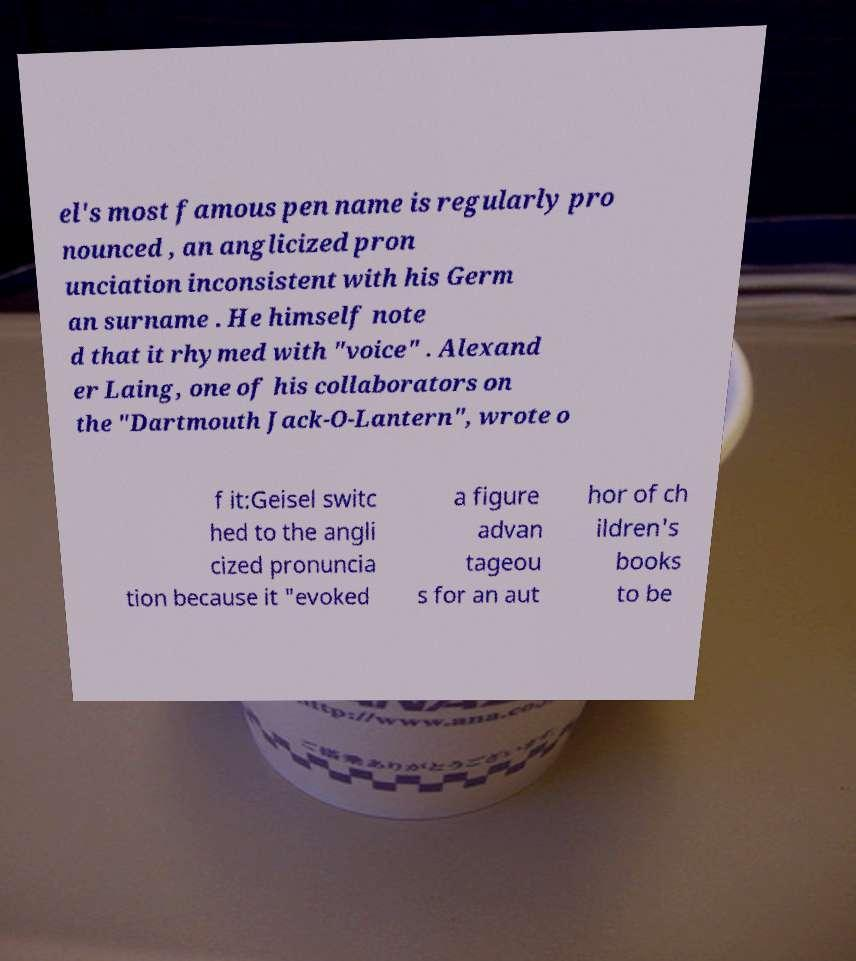Can you read and provide the text displayed in the image?This photo seems to have some interesting text. Can you extract and type it out for me? el's most famous pen name is regularly pro nounced , an anglicized pron unciation inconsistent with his Germ an surname . He himself note d that it rhymed with "voice" . Alexand er Laing, one of his collaborators on the "Dartmouth Jack-O-Lantern", wrote o f it:Geisel switc hed to the angli cized pronuncia tion because it "evoked a figure advan tageou s for an aut hor of ch ildren's books to be 